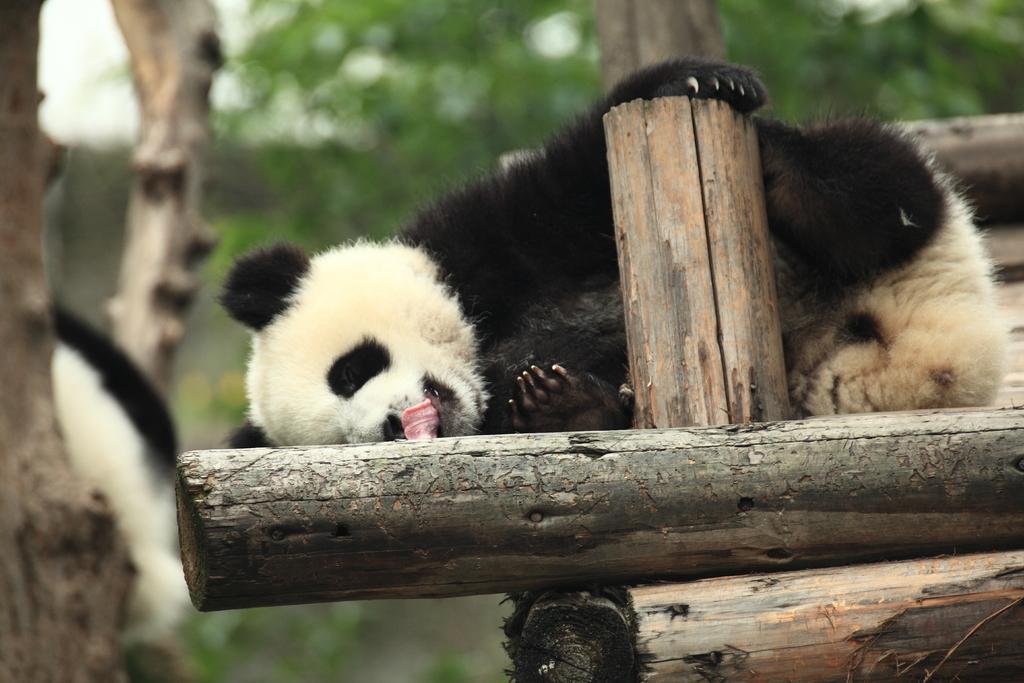Can you describe this image briefly? In this picture we can see a panda lying on wooden poles and in the background we can see trees and it is blurry. 